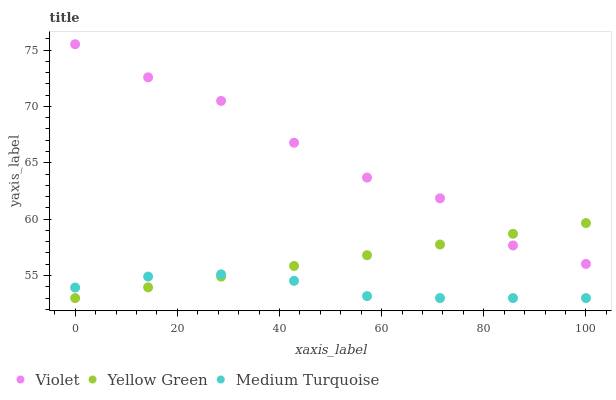Does Medium Turquoise have the minimum area under the curve?
Answer yes or no. Yes. Does Violet have the maximum area under the curve?
Answer yes or no. Yes. Does Violet have the minimum area under the curve?
Answer yes or no. No. Does Medium Turquoise have the maximum area under the curve?
Answer yes or no. No. Is Yellow Green the smoothest?
Answer yes or no. Yes. Is Violet the roughest?
Answer yes or no. Yes. Is Medium Turquoise the smoothest?
Answer yes or no. No. Is Medium Turquoise the roughest?
Answer yes or no. No. Does Yellow Green have the lowest value?
Answer yes or no. Yes. Does Violet have the lowest value?
Answer yes or no. No. Does Violet have the highest value?
Answer yes or no. Yes. Does Medium Turquoise have the highest value?
Answer yes or no. No. Is Medium Turquoise less than Violet?
Answer yes or no. Yes. Is Violet greater than Medium Turquoise?
Answer yes or no. Yes. Does Yellow Green intersect Medium Turquoise?
Answer yes or no. Yes. Is Yellow Green less than Medium Turquoise?
Answer yes or no. No. Is Yellow Green greater than Medium Turquoise?
Answer yes or no. No. Does Medium Turquoise intersect Violet?
Answer yes or no. No. 